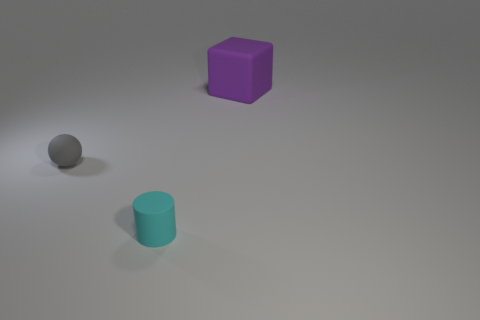Add 1 small rubber objects. How many objects exist? 4 Subtract all cylinders. How many objects are left? 2 Add 1 large cubes. How many large cubes exist? 2 Subtract 0 brown blocks. How many objects are left? 3 Subtract all tiny cyan cylinders. Subtract all small gray objects. How many objects are left? 1 Add 1 blocks. How many blocks are left? 2 